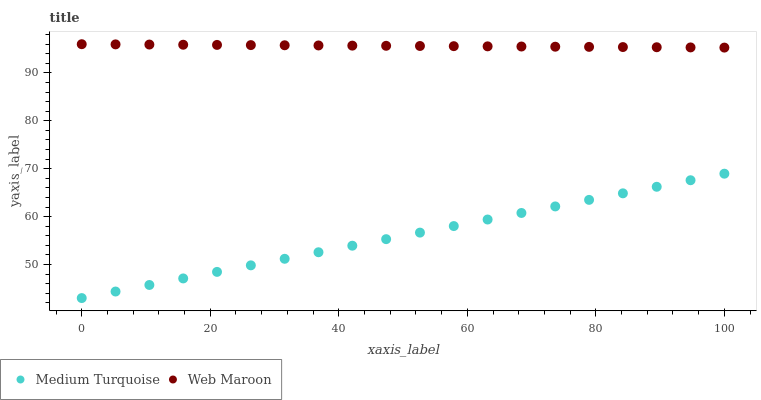Does Medium Turquoise have the minimum area under the curve?
Answer yes or no. Yes. Does Web Maroon have the maximum area under the curve?
Answer yes or no. Yes. Does Medium Turquoise have the maximum area under the curve?
Answer yes or no. No. Is Medium Turquoise the smoothest?
Answer yes or no. Yes. Is Web Maroon the roughest?
Answer yes or no. Yes. Is Medium Turquoise the roughest?
Answer yes or no. No. Does Medium Turquoise have the lowest value?
Answer yes or no. Yes. Does Web Maroon have the highest value?
Answer yes or no. Yes. Does Medium Turquoise have the highest value?
Answer yes or no. No. Is Medium Turquoise less than Web Maroon?
Answer yes or no. Yes. Is Web Maroon greater than Medium Turquoise?
Answer yes or no. Yes. Does Medium Turquoise intersect Web Maroon?
Answer yes or no. No. 